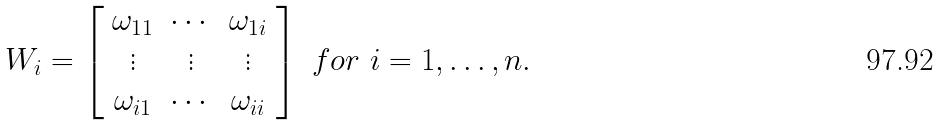Convert formula to latex. <formula><loc_0><loc_0><loc_500><loc_500>W _ { i } = \left [ \begin{array} { c c c } \omega _ { 1 1 } & \cdots & \omega _ { 1 i } \\ \vdots & \vdots & \vdots \\ \omega _ { i 1 } & \cdots & \omega _ { i i } \end{array} \right ] \ f o r \ i = 1 , \dots , n .</formula> 